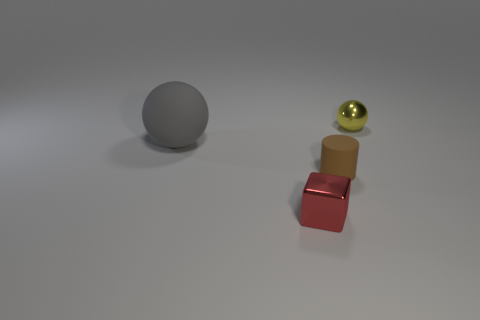There is a sphere to the right of the tiny shiny object that is in front of the small metallic thing that is behind the red thing; how big is it?
Offer a very short reply. Small. What is the material of the brown object?
Give a very brief answer. Rubber. Is the brown thing made of the same material as the sphere that is on the left side of the tiny block?
Make the answer very short. Yes. Are there any other things of the same color as the large sphere?
Make the answer very short. No. Is there a cube that is in front of the small metallic object right of the shiny thing that is to the left of the small yellow metallic ball?
Provide a short and direct response. Yes. What is the color of the big matte object?
Your response must be concise. Gray. There is a tiny rubber thing; are there any small red things in front of it?
Keep it short and to the point. Yes. Is the shape of the large thing the same as the tiny metal object on the left side of the small sphere?
Ensure brevity in your answer.  No. How many other objects are the same material as the tiny ball?
Ensure brevity in your answer.  1. What color is the object to the left of the shiny thing left of the tiny metallic thing that is behind the small matte thing?
Make the answer very short. Gray. 